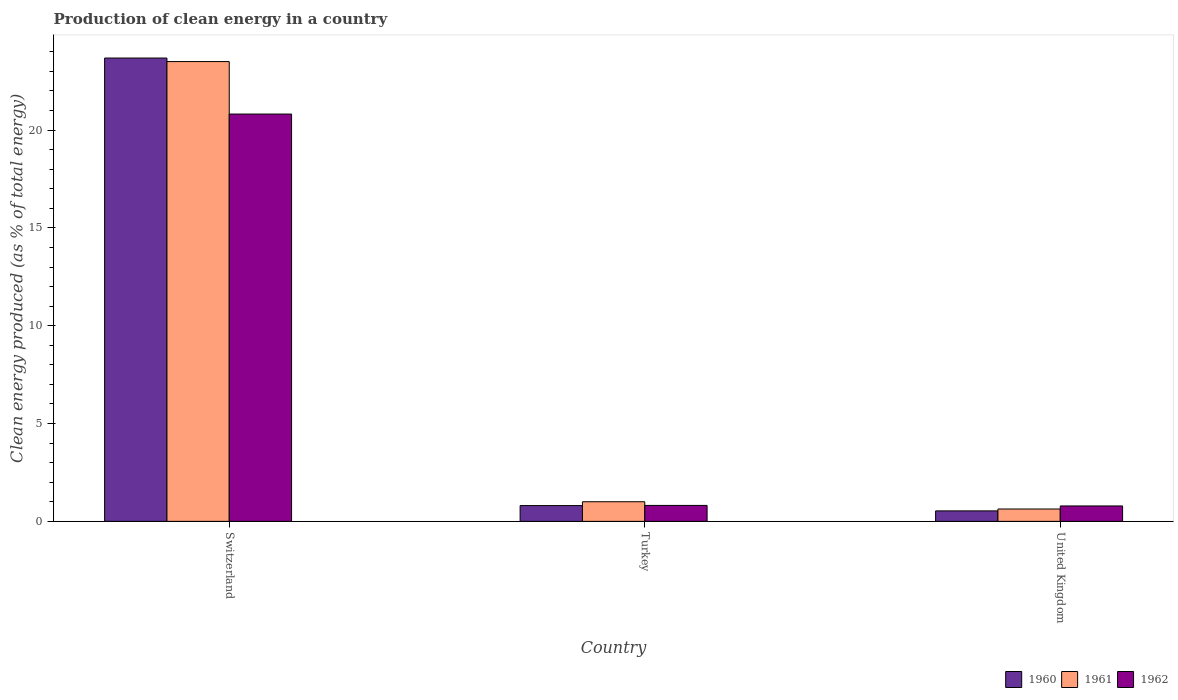How many different coloured bars are there?
Your response must be concise. 3. How many groups of bars are there?
Give a very brief answer. 3. Are the number of bars on each tick of the X-axis equal?
Your response must be concise. Yes. How many bars are there on the 2nd tick from the left?
Your response must be concise. 3. What is the label of the 2nd group of bars from the left?
Make the answer very short. Turkey. In how many cases, is the number of bars for a given country not equal to the number of legend labels?
Make the answer very short. 0. What is the percentage of clean energy produced in 1962 in United Kingdom?
Give a very brief answer. 0.79. Across all countries, what is the maximum percentage of clean energy produced in 1960?
Offer a terse response. 23.68. Across all countries, what is the minimum percentage of clean energy produced in 1961?
Your answer should be compact. 0.63. In which country was the percentage of clean energy produced in 1961 maximum?
Your answer should be compact. Switzerland. What is the total percentage of clean energy produced in 1962 in the graph?
Your answer should be very brief. 22.42. What is the difference between the percentage of clean energy produced in 1961 in Switzerland and that in United Kingdom?
Give a very brief answer. 22.87. What is the difference between the percentage of clean energy produced in 1962 in Turkey and the percentage of clean energy produced in 1961 in Switzerland?
Offer a very short reply. -22.69. What is the average percentage of clean energy produced in 1961 per country?
Provide a short and direct response. 8.38. What is the difference between the percentage of clean energy produced of/in 1962 and percentage of clean energy produced of/in 1960 in Turkey?
Provide a short and direct response. 0.01. In how many countries, is the percentage of clean energy produced in 1960 greater than 10 %?
Ensure brevity in your answer.  1. What is the ratio of the percentage of clean energy produced in 1962 in Switzerland to that in United Kingdom?
Offer a terse response. 26.43. What is the difference between the highest and the second highest percentage of clean energy produced in 1960?
Provide a short and direct response. 0.27. What is the difference between the highest and the lowest percentage of clean energy produced in 1962?
Provide a succinct answer. 20.03. In how many countries, is the percentage of clean energy produced in 1960 greater than the average percentage of clean energy produced in 1960 taken over all countries?
Ensure brevity in your answer.  1. What does the 2nd bar from the left in United Kingdom represents?
Your answer should be compact. 1961. What does the 2nd bar from the right in United Kingdom represents?
Your answer should be compact. 1961. Is it the case that in every country, the sum of the percentage of clean energy produced in 1962 and percentage of clean energy produced in 1961 is greater than the percentage of clean energy produced in 1960?
Make the answer very short. Yes. How many bars are there?
Offer a terse response. 9. Are all the bars in the graph horizontal?
Give a very brief answer. No. What is the difference between two consecutive major ticks on the Y-axis?
Provide a short and direct response. 5. Does the graph contain any zero values?
Your response must be concise. No. Does the graph contain grids?
Provide a short and direct response. No. Where does the legend appear in the graph?
Provide a short and direct response. Bottom right. How many legend labels are there?
Provide a short and direct response. 3. How are the legend labels stacked?
Offer a very short reply. Horizontal. What is the title of the graph?
Keep it short and to the point. Production of clean energy in a country. Does "2005" appear as one of the legend labels in the graph?
Offer a very short reply. No. What is the label or title of the X-axis?
Ensure brevity in your answer.  Country. What is the label or title of the Y-axis?
Keep it short and to the point. Clean energy produced (as % of total energy). What is the Clean energy produced (as % of total energy) of 1960 in Switzerland?
Your answer should be very brief. 23.68. What is the Clean energy produced (as % of total energy) of 1961 in Switzerland?
Give a very brief answer. 23.5. What is the Clean energy produced (as % of total energy) of 1962 in Switzerland?
Your response must be concise. 20.82. What is the Clean energy produced (as % of total energy) of 1960 in Turkey?
Provide a short and direct response. 0.81. What is the Clean energy produced (as % of total energy) of 1961 in Turkey?
Keep it short and to the point. 1. What is the Clean energy produced (as % of total energy) of 1962 in Turkey?
Give a very brief answer. 0.82. What is the Clean energy produced (as % of total energy) of 1960 in United Kingdom?
Make the answer very short. 0.54. What is the Clean energy produced (as % of total energy) of 1961 in United Kingdom?
Give a very brief answer. 0.63. What is the Clean energy produced (as % of total energy) in 1962 in United Kingdom?
Make the answer very short. 0.79. Across all countries, what is the maximum Clean energy produced (as % of total energy) of 1960?
Your answer should be compact. 23.68. Across all countries, what is the maximum Clean energy produced (as % of total energy) of 1961?
Offer a terse response. 23.5. Across all countries, what is the maximum Clean energy produced (as % of total energy) of 1962?
Ensure brevity in your answer.  20.82. Across all countries, what is the minimum Clean energy produced (as % of total energy) in 1960?
Your answer should be compact. 0.54. Across all countries, what is the minimum Clean energy produced (as % of total energy) in 1961?
Keep it short and to the point. 0.63. Across all countries, what is the minimum Clean energy produced (as % of total energy) in 1962?
Offer a very short reply. 0.79. What is the total Clean energy produced (as % of total energy) of 1960 in the graph?
Keep it short and to the point. 25.02. What is the total Clean energy produced (as % of total energy) of 1961 in the graph?
Keep it short and to the point. 25.14. What is the total Clean energy produced (as % of total energy) in 1962 in the graph?
Give a very brief answer. 22.42. What is the difference between the Clean energy produced (as % of total energy) of 1960 in Switzerland and that in Turkey?
Provide a succinct answer. 22.88. What is the difference between the Clean energy produced (as % of total energy) in 1961 in Switzerland and that in Turkey?
Make the answer very short. 22.5. What is the difference between the Clean energy produced (as % of total energy) of 1962 in Switzerland and that in Turkey?
Ensure brevity in your answer.  20. What is the difference between the Clean energy produced (as % of total energy) of 1960 in Switzerland and that in United Kingdom?
Give a very brief answer. 23.15. What is the difference between the Clean energy produced (as % of total energy) of 1961 in Switzerland and that in United Kingdom?
Offer a very short reply. 22.87. What is the difference between the Clean energy produced (as % of total energy) of 1962 in Switzerland and that in United Kingdom?
Your response must be concise. 20.03. What is the difference between the Clean energy produced (as % of total energy) in 1960 in Turkey and that in United Kingdom?
Give a very brief answer. 0.27. What is the difference between the Clean energy produced (as % of total energy) of 1961 in Turkey and that in United Kingdom?
Your answer should be compact. 0.37. What is the difference between the Clean energy produced (as % of total energy) in 1962 in Turkey and that in United Kingdom?
Provide a short and direct response. 0.03. What is the difference between the Clean energy produced (as % of total energy) in 1960 in Switzerland and the Clean energy produced (as % of total energy) in 1961 in Turkey?
Your answer should be very brief. 22.68. What is the difference between the Clean energy produced (as % of total energy) of 1960 in Switzerland and the Clean energy produced (as % of total energy) of 1962 in Turkey?
Offer a very short reply. 22.87. What is the difference between the Clean energy produced (as % of total energy) in 1961 in Switzerland and the Clean energy produced (as % of total energy) in 1962 in Turkey?
Your answer should be compact. 22.69. What is the difference between the Clean energy produced (as % of total energy) of 1960 in Switzerland and the Clean energy produced (as % of total energy) of 1961 in United Kingdom?
Give a very brief answer. 23.05. What is the difference between the Clean energy produced (as % of total energy) in 1960 in Switzerland and the Clean energy produced (as % of total energy) in 1962 in United Kingdom?
Your response must be concise. 22.89. What is the difference between the Clean energy produced (as % of total energy) of 1961 in Switzerland and the Clean energy produced (as % of total energy) of 1962 in United Kingdom?
Your answer should be very brief. 22.71. What is the difference between the Clean energy produced (as % of total energy) in 1960 in Turkey and the Clean energy produced (as % of total energy) in 1961 in United Kingdom?
Your response must be concise. 0.17. What is the difference between the Clean energy produced (as % of total energy) of 1960 in Turkey and the Clean energy produced (as % of total energy) of 1962 in United Kingdom?
Offer a very short reply. 0.02. What is the difference between the Clean energy produced (as % of total energy) in 1961 in Turkey and the Clean energy produced (as % of total energy) in 1962 in United Kingdom?
Your answer should be compact. 0.21. What is the average Clean energy produced (as % of total energy) in 1960 per country?
Ensure brevity in your answer.  8.34. What is the average Clean energy produced (as % of total energy) of 1961 per country?
Your answer should be very brief. 8.38. What is the average Clean energy produced (as % of total energy) of 1962 per country?
Provide a succinct answer. 7.47. What is the difference between the Clean energy produced (as % of total energy) in 1960 and Clean energy produced (as % of total energy) in 1961 in Switzerland?
Make the answer very short. 0.18. What is the difference between the Clean energy produced (as % of total energy) of 1960 and Clean energy produced (as % of total energy) of 1962 in Switzerland?
Provide a short and direct response. 2.86. What is the difference between the Clean energy produced (as % of total energy) in 1961 and Clean energy produced (as % of total energy) in 1962 in Switzerland?
Your answer should be compact. 2.68. What is the difference between the Clean energy produced (as % of total energy) in 1960 and Clean energy produced (as % of total energy) in 1961 in Turkey?
Offer a terse response. -0.2. What is the difference between the Clean energy produced (as % of total energy) in 1960 and Clean energy produced (as % of total energy) in 1962 in Turkey?
Offer a very short reply. -0.01. What is the difference between the Clean energy produced (as % of total energy) in 1961 and Clean energy produced (as % of total energy) in 1962 in Turkey?
Provide a succinct answer. 0.19. What is the difference between the Clean energy produced (as % of total energy) in 1960 and Clean energy produced (as % of total energy) in 1961 in United Kingdom?
Make the answer very short. -0.1. What is the difference between the Clean energy produced (as % of total energy) in 1960 and Clean energy produced (as % of total energy) in 1962 in United Kingdom?
Offer a terse response. -0.25. What is the difference between the Clean energy produced (as % of total energy) in 1961 and Clean energy produced (as % of total energy) in 1962 in United Kingdom?
Provide a short and direct response. -0.16. What is the ratio of the Clean energy produced (as % of total energy) in 1960 in Switzerland to that in Turkey?
Provide a short and direct response. 29.38. What is the ratio of the Clean energy produced (as % of total energy) of 1961 in Switzerland to that in Turkey?
Offer a terse response. 23.44. What is the ratio of the Clean energy produced (as % of total energy) in 1962 in Switzerland to that in Turkey?
Give a very brief answer. 25.53. What is the ratio of the Clean energy produced (as % of total energy) of 1960 in Switzerland to that in United Kingdom?
Offer a very short reply. 44.24. What is the ratio of the Clean energy produced (as % of total energy) in 1961 in Switzerland to that in United Kingdom?
Your answer should be compact. 37.21. What is the ratio of the Clean energy produced (as % of total energy) of 1962 in Switzerland to that in United Kingdom?
Ensure brevity in your answer.  26.43. What is the ratio of the Clean energy produced (as % of total energy) of 1960 in Turkey to that in United Kingdom?
Provide a short and direct response. 1.51. What is the ratio of the Clean energy produced (as % of total energy) in 1961 in Turkey to that in United Kingdom?
Your answer should be very brief. 1.59. What is the ratio of the Clean energy produced (as % of total energy) in 1962 in Turkey to that in United Kingdom?
Offer a terse response. 1.04. What is the difference between the highest and the second highest Clean energy produced (as % of total energy) in 1960?
Provide a short and direct response. 22.88. What is the difference between the highest and the second highest Clean energy produced (as % of total energy) of 1961?
Offer a very short reply. 22.5. What is the difference between the highest and the second highest Clean energy produced (as % of total energy) in 1962?
Ensure brevity in your answer.  20. What is the difference between the highest and the lowest Clean energy produced (as % of total energy) in 1960?
Ensure brevity in your answer.  23.15. What is the difference between the highest and the lowest Clean energy produced (as % of total energy) in 1961?
Your answer should be very brief. 22.87. What is the difference between the highest and the lowest Clean energy produced (as % of total energy) of 1962?
Your answer should be compact. 20.03. 